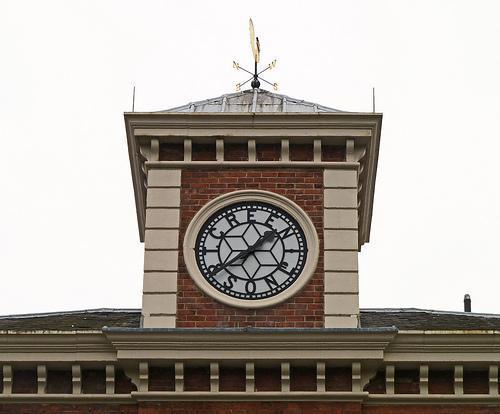How many letters on the clock?
Give a very brief answer. 12. 